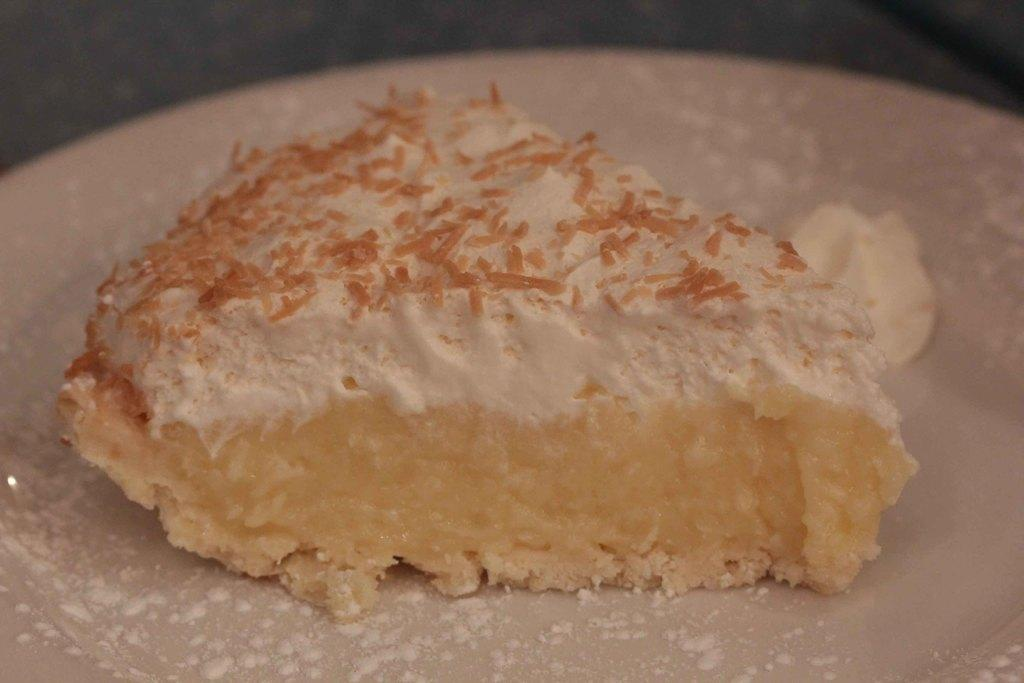What is the main subject of the image? The main subject of the image is a piece of cake. How is the piece of cake presented in the image? The piece of cake is in a plate. What additional detail can be observed in the plate? There is white powder in the plate. What type of shoe can be seen in the image? There is no shoe present in the image. 